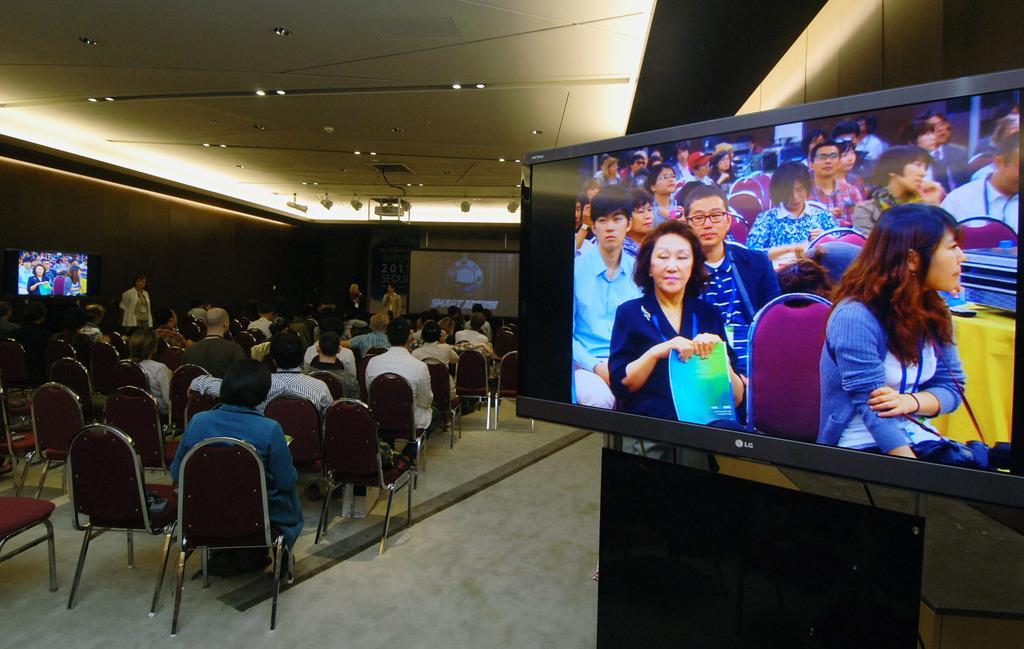Describe this image in one or two sentences. In the given image we can see many people sitting on chair. This is a TV. This is a projector. 